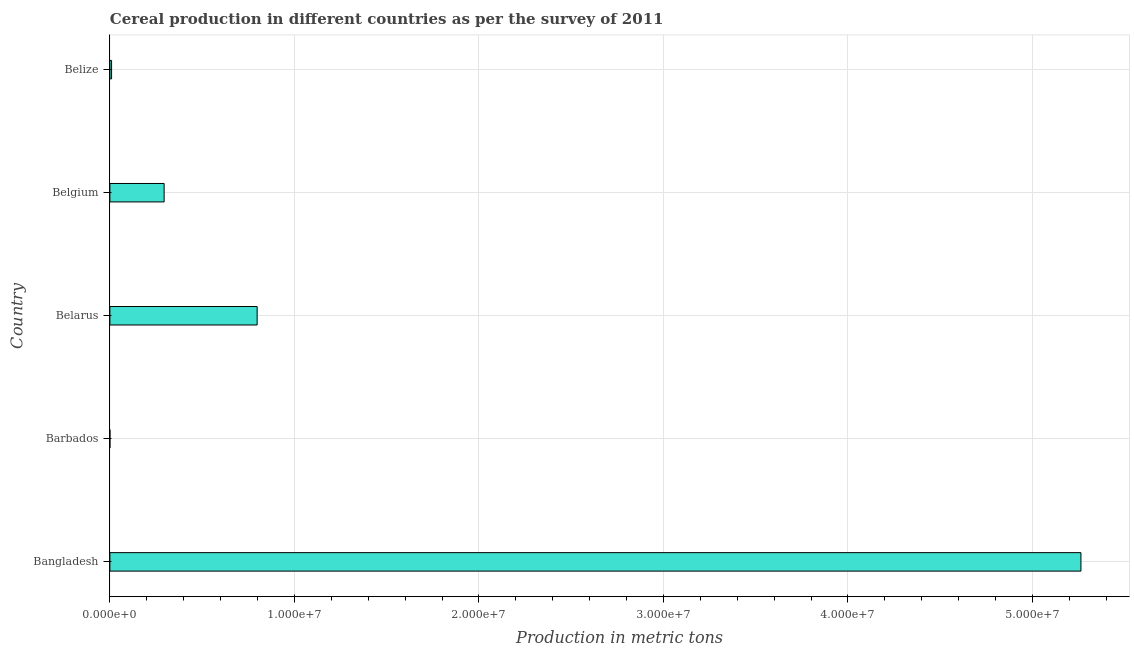Does the graph contain grids?
Offer a terse response. Yes. What is the title of the graph?
Offer a very short reply. Cereal production in different countries as per the survey of 2011. What is the label or title of the X-axis?
Offer a very short reply. Production in metric tons. What is the label or title of the Y-axis?
Your answer should be very brief. Country. What is the cereal production in Barbados?
Provide a succinct answer. 310. Across all countries, what is the maximum cereal production?
Offer a very short reply. 5.26e+07. Across all countries, what is the minimum cereal production?
Your answer should be compact. 310. In which country was the cereal production maximum?
Make the answer very short. Bangladesh. In which country was the cereal production minimum?
Provide a short and direct response. Barbados. What is the sum of the cereal production?
Your answer should be compact. 6.36e+07. What is the difference between the cereal production in Bangladesh and Belgium?
Ensure brevity in your answer.  4.97e+07. What is the average cereal production per country?
Provide a short and direct response. 1.27e+07. What is the median cereal production?
Make the answer very short. 2.94e+06. What is the ratio of the cereal production in Bangladesh to that in Belarus?
Offer a very short reply. 6.59. Is the difference between the cereal production in Barbados and Belgium greater than the difference between any two countries?
Offer a very short reply. No. What is the difference between the highest and the second highest cereal production?
Make the answer very short. 4.46e+07. Is the sum of the cereal production in Belgium and Belize greater than the maximum cereal production across all countries?
Offer a very short reply. No. What is the difference between the highest and the lowest cereal production?
Your answer should be compact. 5.26e+07. What is the difference between two consecutive major ticks on the X-axis?
Make the answer very short. 1.00e+07. Are the values on the major ticks of X-axis written in scientific E-notation?
Offer a very short reply. Yes. What is the Production in metric tons in Bangladesh?
Give a very brief answer. 5.26e+07. What is the Production in metric tons of Barbados?
Provide a succinct answer. 310. What is the Production in metric tons of Belarus?
Provide a succinct answer. 7.98e+06. What is the Production in metric tons of Belgium?
Your response must be concise. 2.94e+06. What is the Production in metric tons of Belize?
Provide a short and direct response. 9.18e+04. What is the difference between the Production in metric tons in Bangladesh and Barbados?
Ensure brevity in your answer.  5.26e+07. What is the difference between the Production in metric tons in Bangladesh and Belarus?
Your response must be concise. 4.46e+07. What is the difference between the Production in metric tons in Bangladesh and Belgium?
Your answer should be very brief. 4.97e+07. What is the difference between the Production in metric tons in Bangladesh and Belize?
Provide a succinct answer. 5.25e+07. What is the difference between the Production in metric tons in Barbados and Belarus?
Keep it short and to the point. -7.98e+06. What is the difference between the Production in metric tons in Barbados and Belgium?
Provide a succinct answer. -2.94e+06. What is the difference between the Production in metric tons in Barbados and Belize?
Provide a short and direct response. -9.15e+04. What is the difference between the Production in metric tons in Belarus and Belgium?
Make the answer very short. 5.04e+06. What is the difference between the Production in metric tons in Belarus and Belize?
Provide a short and direct response. 7.89e+06. What is the difference between the Production in metric tons in Belgium and Belize?
Provide a short and direct response. 2.85e+06. What is the ratio of the Production in metric tons in Bangladesh to that in Barbados?
Keep it short and to the point. 1.70e+05. What is the ratio of the Production in metric tons in Bangladesh to that in Belarus?
Offer a terse response. 6.59. What is the ratio of the Production in metric tons in Bangladesh to that in Belgium?
Your answer should be very brief. 17.91. What is the ratio of the Production in metric tons in Bangladesh to that in Belize?
Your answer should be compact. 573.5. What is the ratio of the Production in metric tons in Barbados to that in Belarus?
Your answer should be very brief. 0. What is the ratio of the Production in metric tons in Barbados to that in Belize?
Make the answer very short. 0. What is the ratio of the Production in metric tons in Belarus to that in Belgium?
Your response must be concise. 2.71. What is the ratio of the Production in metric tons in Belarus to that in Belize?
Ensure brevity in your answer.  86.97. What is the ratio of the Production in metric tons in Belgium to that in Belize?
Your response must be concise. 32.03. 